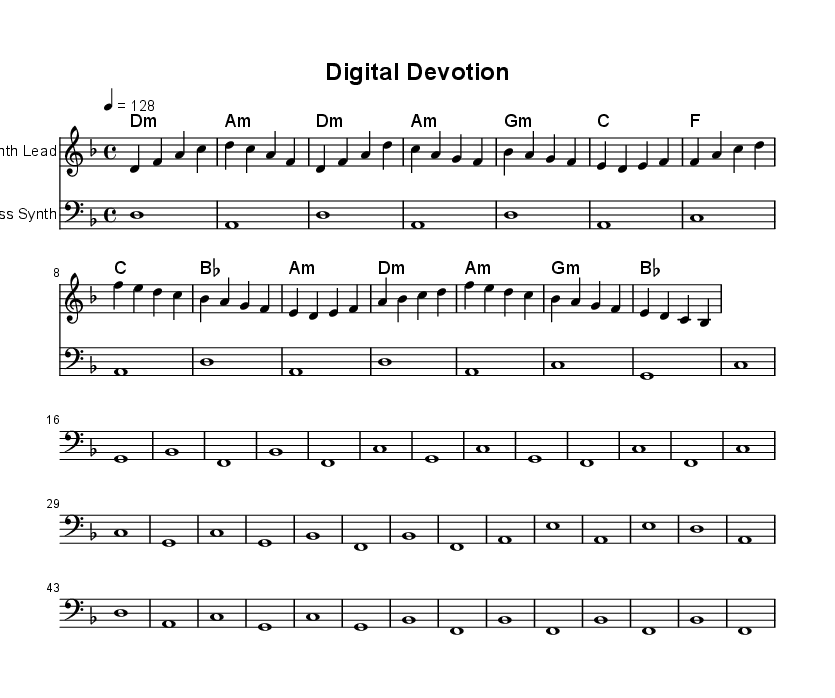What is the key signature of this music? The key signature indicates D minor, which has one flat (B flat). It can be confirmed by identifying the key signature at the beginning of the staff.
Answer: D minor What is the time signature of this music? The time signature, found at the beginning of the score, is 4/4, which means there are four beats per measure and a quarter note gets one beat.
Answer: 4/4 What is the tempo marking of this music? The tempo marking is indicated by "4 = 128" at the top of the score, meaning there are 128 beats per minute.
Answer: 128 How many measures are in the chorus section? By examining the structure, the chorus spans 4 measures: it includes the lines designated for the chorus in the melody and harmonies.
Answer: 4 Which instrument is indicated for the melody part? The melody staff is labeled as "Synth Lead," which indicates the intended instrument to play this part.
Answer: Synth Lead What type of chord is used in the bridge section? The bridge features a combination of D minor, A minor, G minor, and B flat. Each of these represents a different chord, but they all are common in religious electronica to evoke a spiritual sense.
Answer: D minor, A minor, G minor, B flat What is the overall structure of the piece? The music is organized into sections labeled as Intro, Verse, Chorus, and Bridge, which are common in many song formats and provide a cycle of spiritual exploration through music.
Answer: Intro, Verse, Chorus, Bridge 